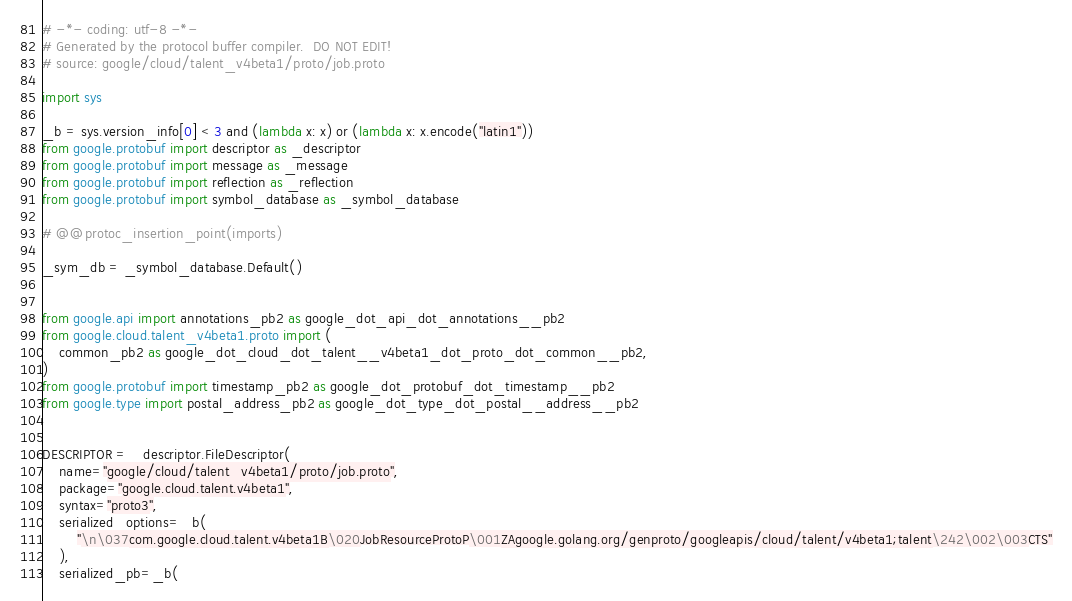Convert code to text. <code><loc_0><loc_0><loc_500><loc_500><_Python_># -*- coding: utf-8 -*-
# Generated by the protocol buffer compiler.  DO NOT EDIT!
# source: google/cloud/talent_v4beta1/proto/job.proto

import sys

_b = sys.version_info[0] < 3 and (lambda x: x) or (lambda x: x.encode("latin1"))
from google.protobuf import descriptor as _descriptor
from google.protobuf import message as _message
from google.protobuf import reflection as _reflection
from google.protobuf import symbol_database as _symbol_database

# @@protoc_insertion_point(imports)

_sym_db = _symbol_database.Default()


from google.api import annotations_pb2 as google_dot_api_dot_annotations__pb2
from google.cloud.talent_v4beta1.proto import (
    common_pb2 as google_dot_cloud_dot_talent__v4beta1_dot_proto_dot_common__pb2,
)
from google.protobuf import timestamp_pb2 as google_dot_protobuf_dot_timestamp__pb2
from google.type import postal_address_pb2 as google_dot_type_dot_postal__address__pb2


DESCRIPTOR = _descriptor.FileDescriptor(
    name="google/cloud/talent_v4beta1/proto/job.proto",
    package="google.cloud.talent.v4beta1",
    syntax="proto3",
    serialized_options=_b(
        "\n\037com.google.cloud.talent.v4beta1B\020JobResourceProtoP\001ZAgoogle.golang.org/genproto/googleapis/cloud/talent/v4beta1;talent\242\002\003CTS"
    ),
    serialized_pb=_b(</code> 